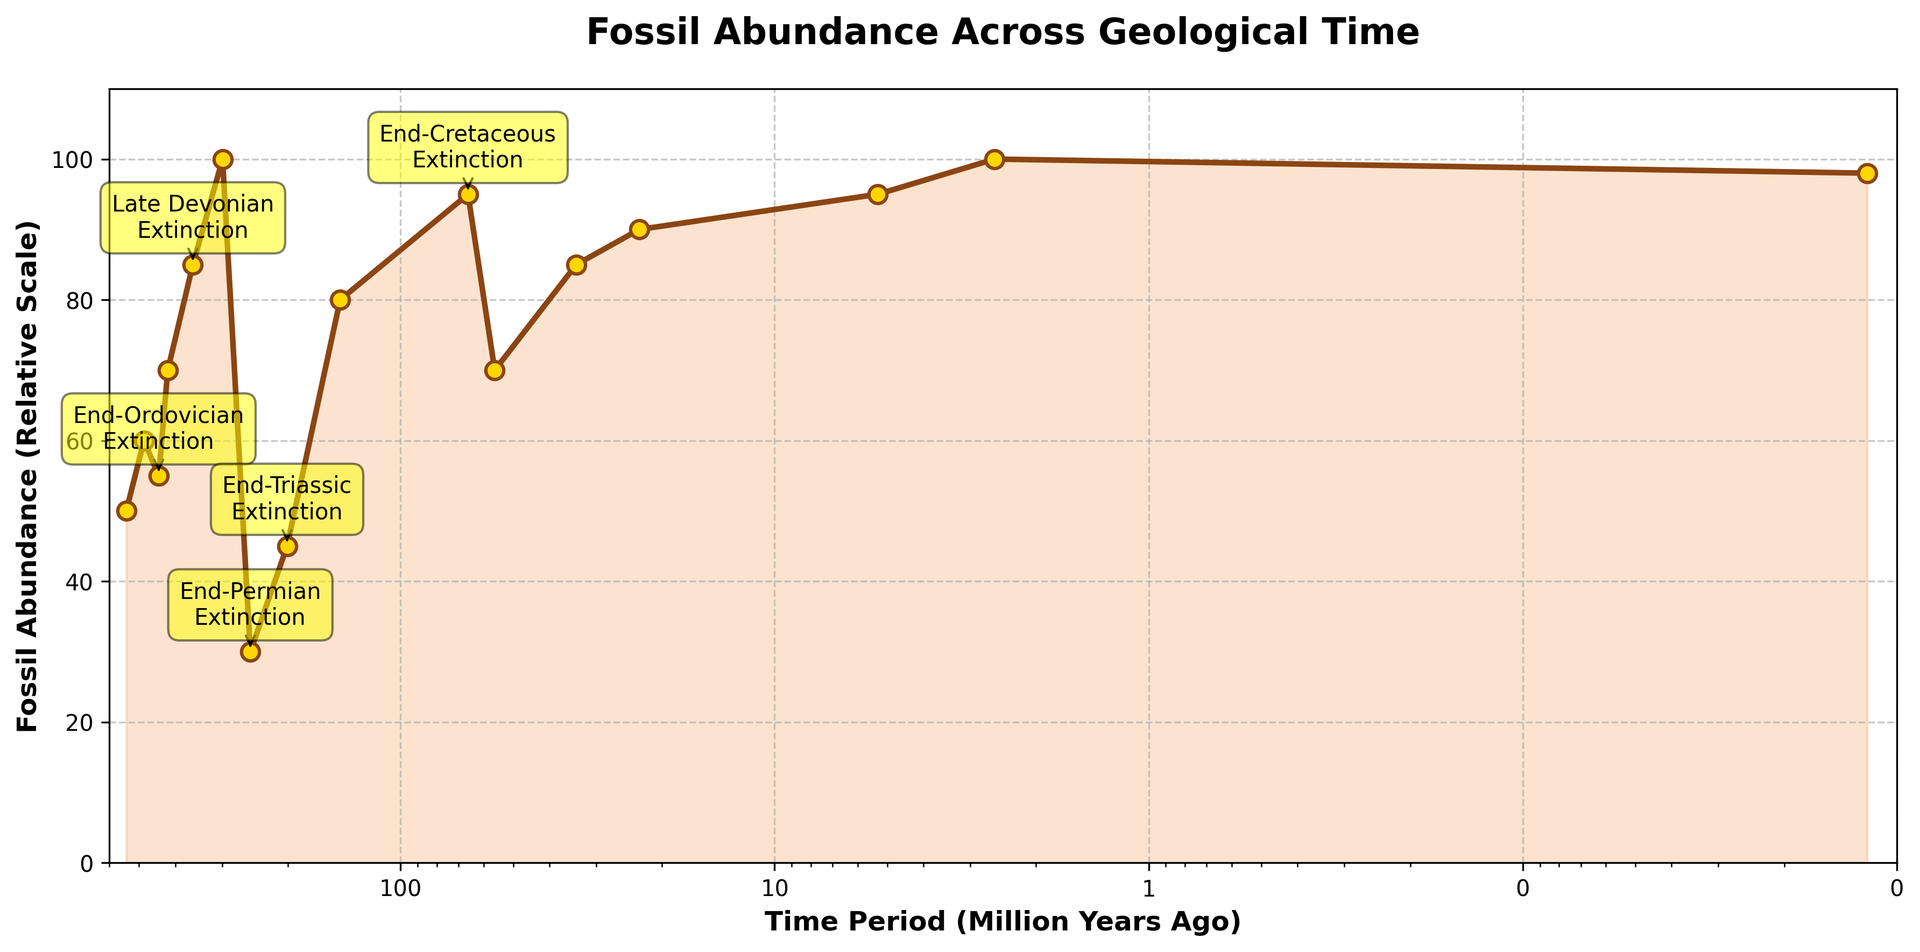What are the time periods associated with the major extinction events annotated in the figure? To find this information, look at the labels and arrows pointing to specific points on the graph. The major extinction events are annotated with their names and time periods.
Answer: End-Permian: 252 MYA, End-Cretaceous: 66 MYA, End-Ordovician: 443 MYA, Late Devonian: 359 MYA, End-Triassic: 201 MYA Which time period shows the highest fossil abundance? The highest point on the y-axis represents the highest fossil abundance. Locate this point and check its corresponding x-axis value.
Answer: 2.58 MYA What is the relative fossil abundance at 56 million years ago compared to 66 million years ago? Identify the y-values at 56 MYA and 66 MYA on the graph and compare them. The y-value at 56 MYA is less than at 66 MYA.
Answer: 56 MYA: 70, 66 MYA: 95 During which extinction event did the fossil abundance drop to the lowest point in the figure? Look for the point with the lowest y-value and check its annotation. The annotation will indicate the associated extinction event.
Answer: End-Permian Extinction at 252 MYA What is the relative increase in fossil abundance from 201 million years ago to 145 million years ago? Find the y-values for 201 MYA and 145 MYA, then calculate the difference between them.
Answer: 145 MYA: 80, 201 MYA: 45, increase: 35 Which period shows a higher fossil abundance, at 443 million years ago or 485 million years ago? Compare the y-values at 443 MYA and 485 MYA on the graph. The y-value indicates fossil abundance.
Answer: 485 MYA How many major extinction events are annotated in the figure? Count the number of annotated labels on the figure pointing to specific time periods.
Answer: 5 What is the trend in fossil abundance from 541 million years ago to 485 million years ago? Observe the slope of the line between these two points on the graph. The slope indicates the trend.
Answer: Increasing What is the maximum fossil abundance after the End-Cretaceous Extinction around 66 million years ago? Look at the y-values to the right of the 66 MYA point and find the maximum value.
Answer: 100 What color is used to fill the area under the curve in the figure? Identify the color used in the filled area under the line in the graph.
Answer: Light brown (sandy brown) 